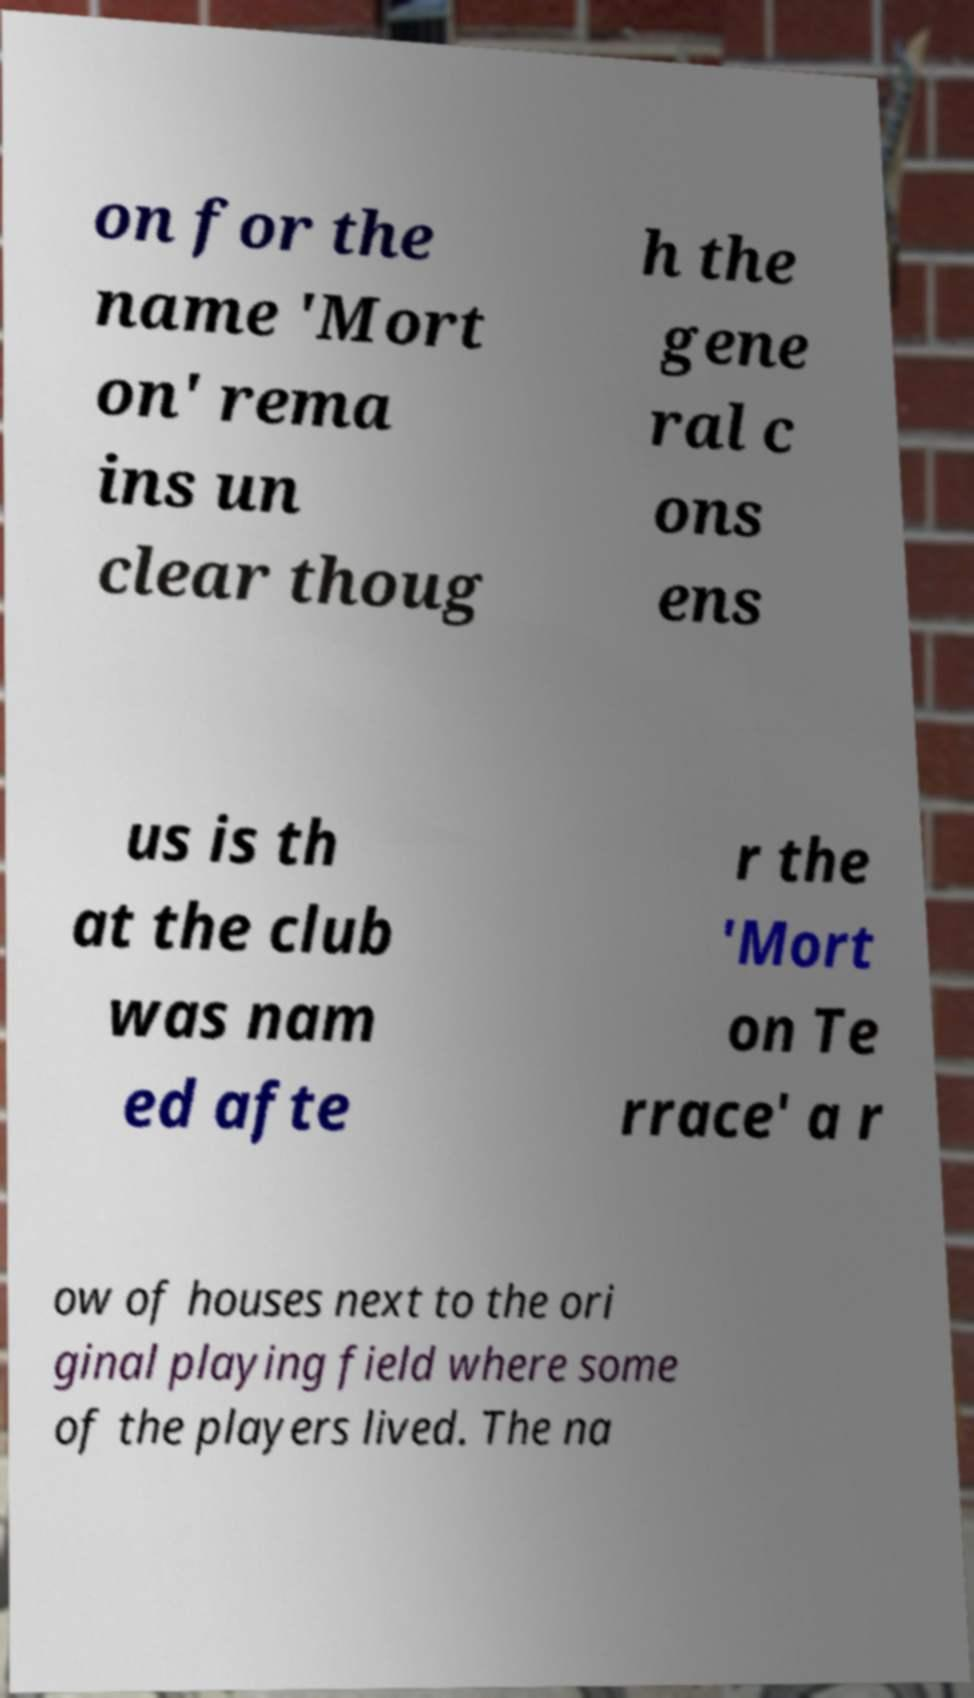There's text embedded in this image that I need extracted. Can you transcribe it verbatim? on for the name 'Mort on' rema ins un clear thoug h the gene ral c ons ens us is th at the club was nam ed afte r the 'Mort on Te rrace' a r ow of houses next to the ori ginal playing field where some of the players lived. The na 